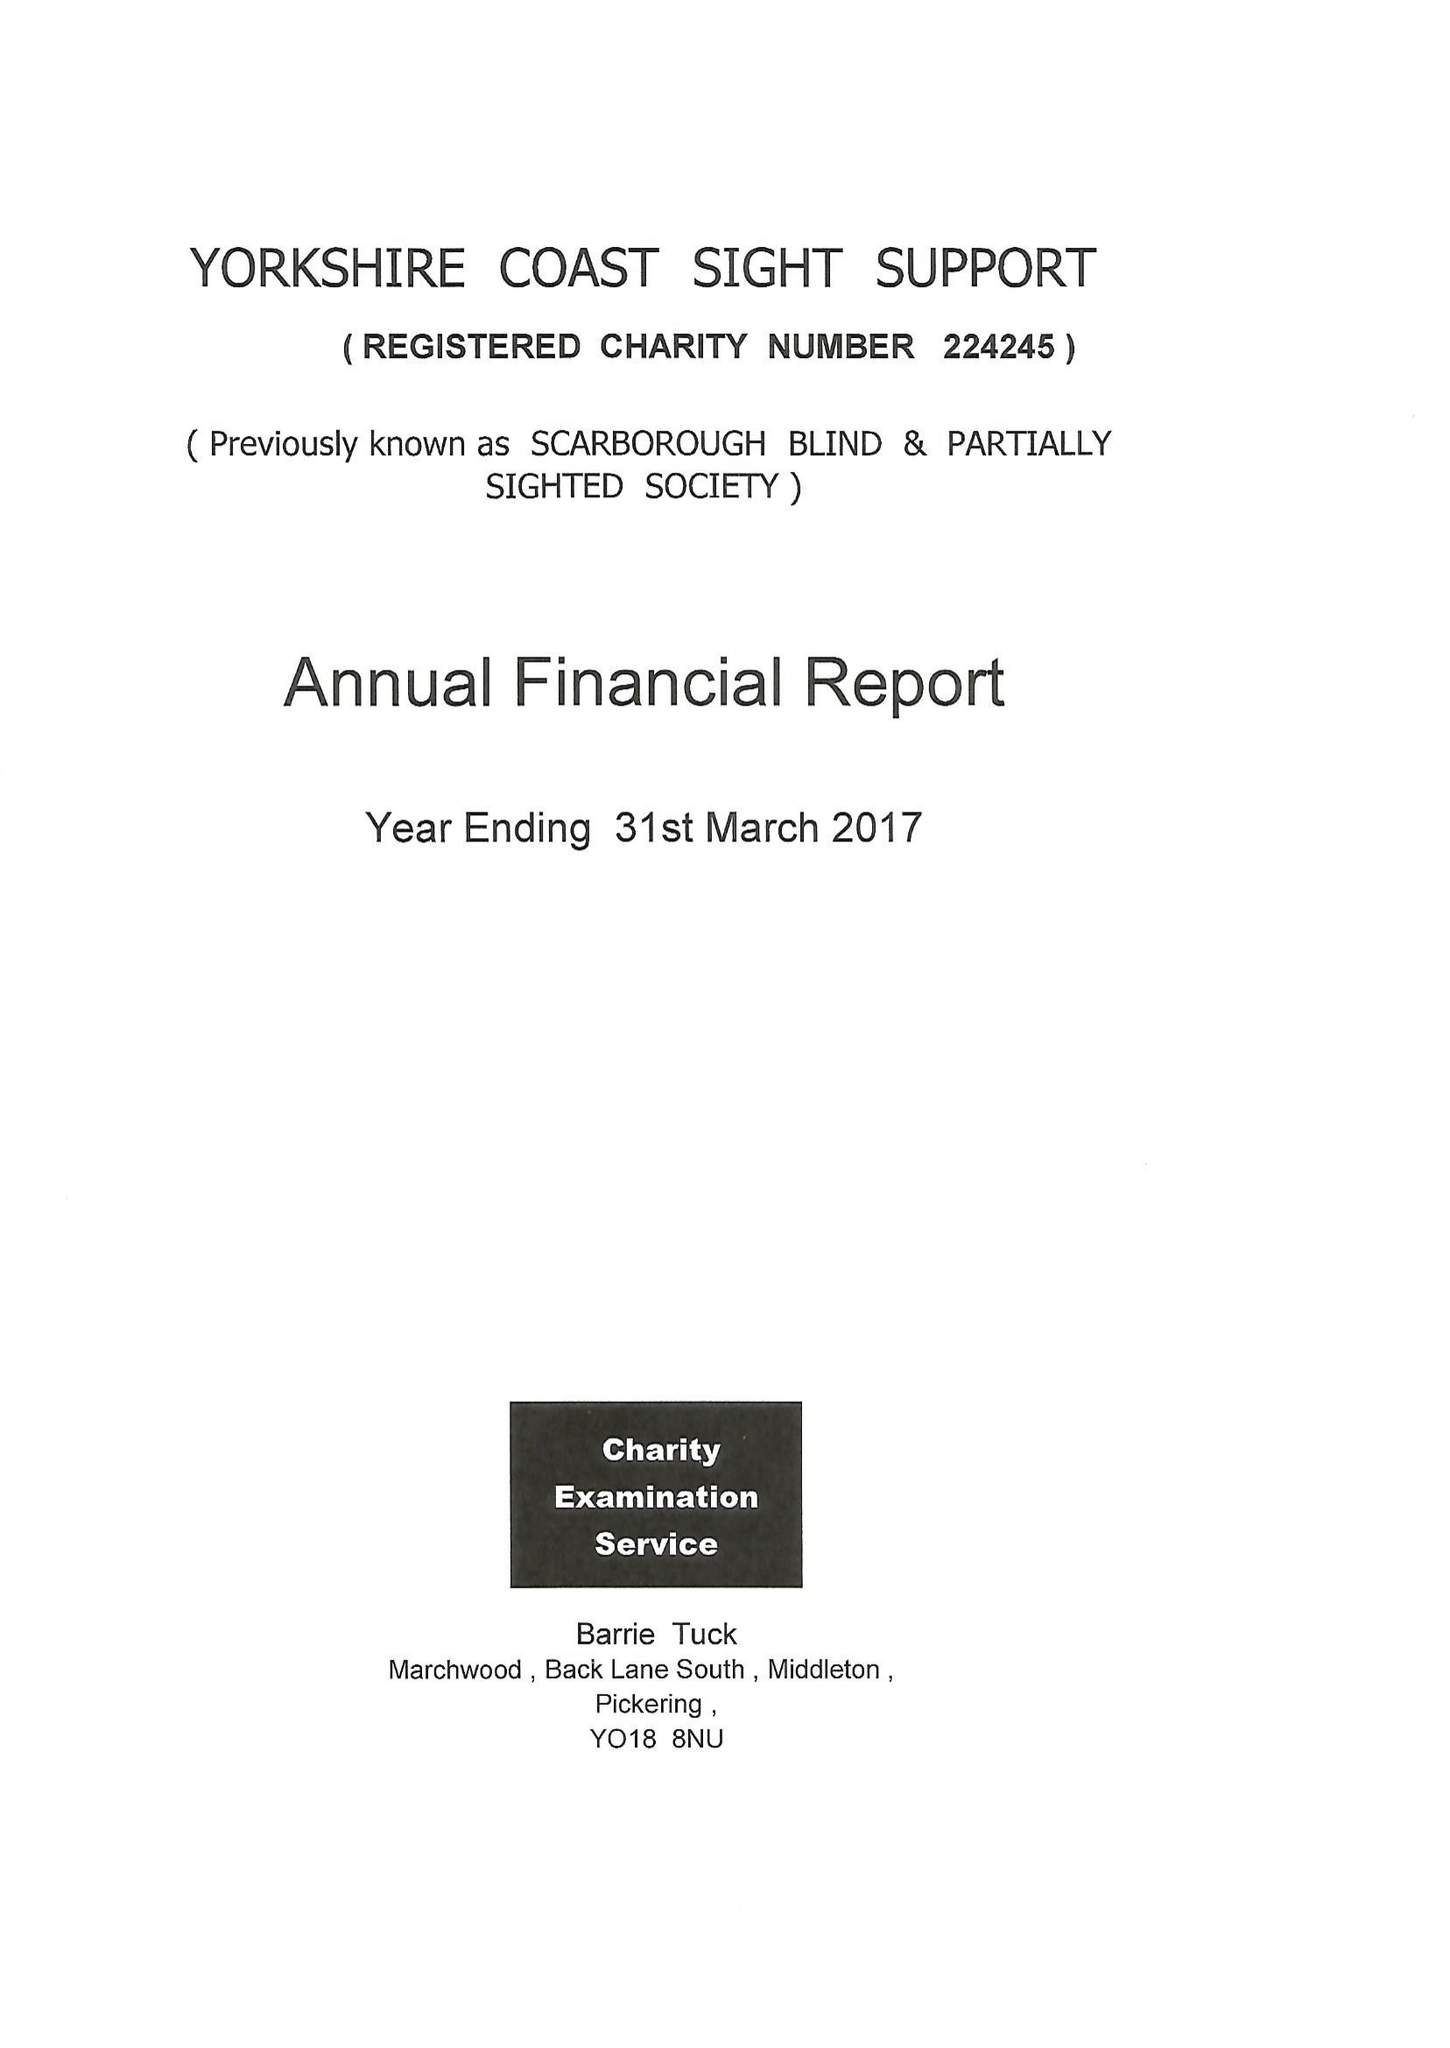What is the value for the address__post_town?
Answer the question using a single word or phrase. SCARBOROUGH 